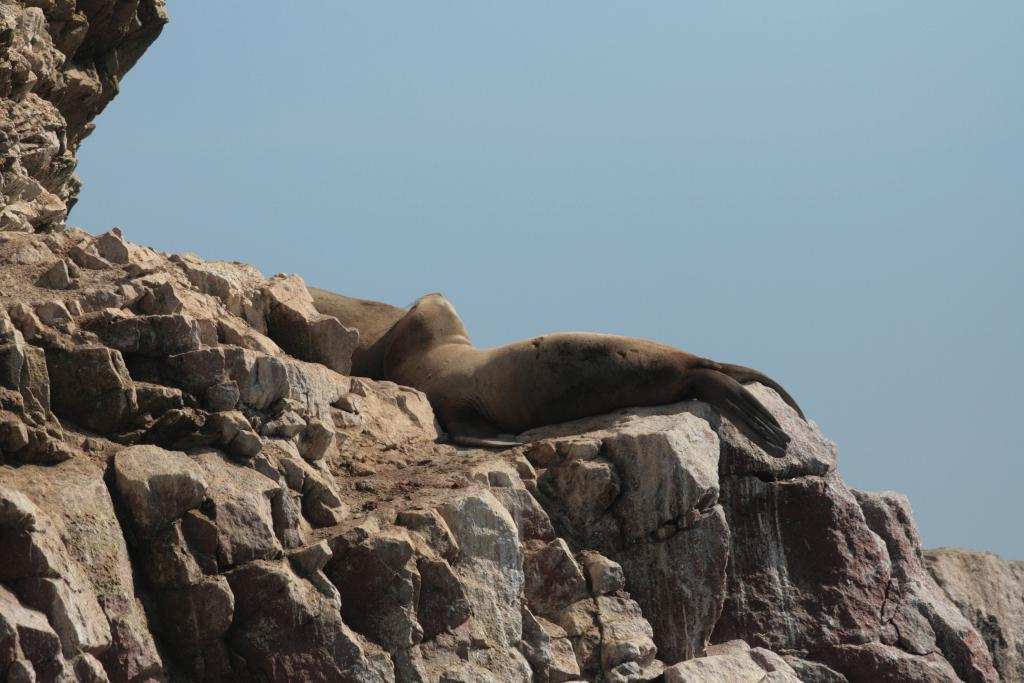What type of creature is in the image? There is a marine animal in the image. Where is the marine animal located? The marine animal is laying on rocks. What is visible at the top of the image? The sky is visible at the top of the image. What type of sugar is being used to clean the marine animal's teeth in the image? There is no sugar or toothpaste present in the image, and the marine animal's teeth are not being cleaned. 